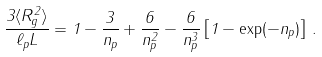<formula> <loc_0><loc_0><loc_500><loc_500>\frac { 3 \langle R ^ { 2 } _ { g } \rangle } { \ell _ { p } L } = 1 - \frac { 3 } { n _ { p } } + \frac { 6 } { n ^ { 2 } _ { p } } - \frac { 6 } { n ^ { 3 } _ { p } } \left [ 1 - \exp ( - n _ { p } ) \right ] \, .</formula> 